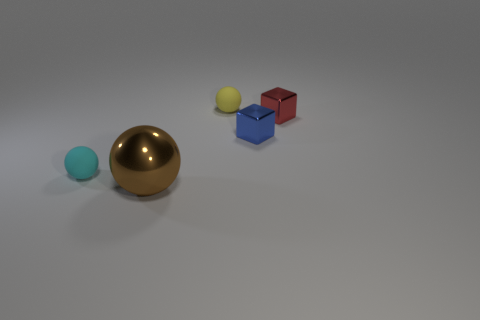What is the shape of the brown metallic object?
Offer a very short reply. Sphere. Is the shiny sphere the same size as the cyan matte ball?
Keep it short and to the point. No. What number of other objects are there of the same shape as the large brown metallic object?
Provide a succinct answer. 2. The tiny matte object that is right of the brown metallic sphere has what shape?
Keep it short and to the point. Sphere. Does the rubber thing that is to the left of the brown metallic ball have the same shape as the brown metallic thing on the left side of the small blue shiny object?
Ensure brevity in your answer.  Yes. Are there the same number of blue metallic objects that are on the left side of the blue shiny thing and metallic objects?
Your response must be concise. No. Are there any other things that are the same size as the brown shiny thing?
Your answer should be compact. No. What is the material of the cyan thing that is the same shape as the big brown object?
Provide a short and direct response. Rubber. What is the shape of the object that is in front of the object that is to the left of the brown thing?
Give a very brief answer. Sphere. Do the sphere that is on the left side of the big brown sphere and the red object have the same material?
Make the answer very short. No. 